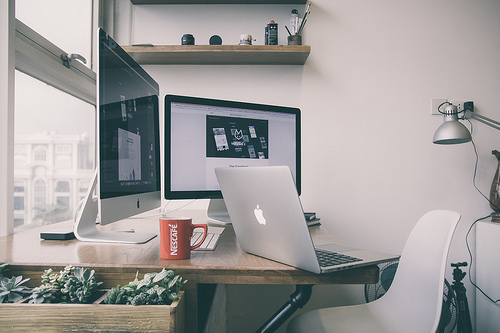<image>
Is the laptop under the coffee mug? No. The laptop is not positioned under the coffee mug. The vertical relationship between these objects is different. Is there a monitor behind the laptop? Yes. From this viewpoint, the monitor is positioned behind the laptop, with the laptop partially or fully occluding the monitor. 